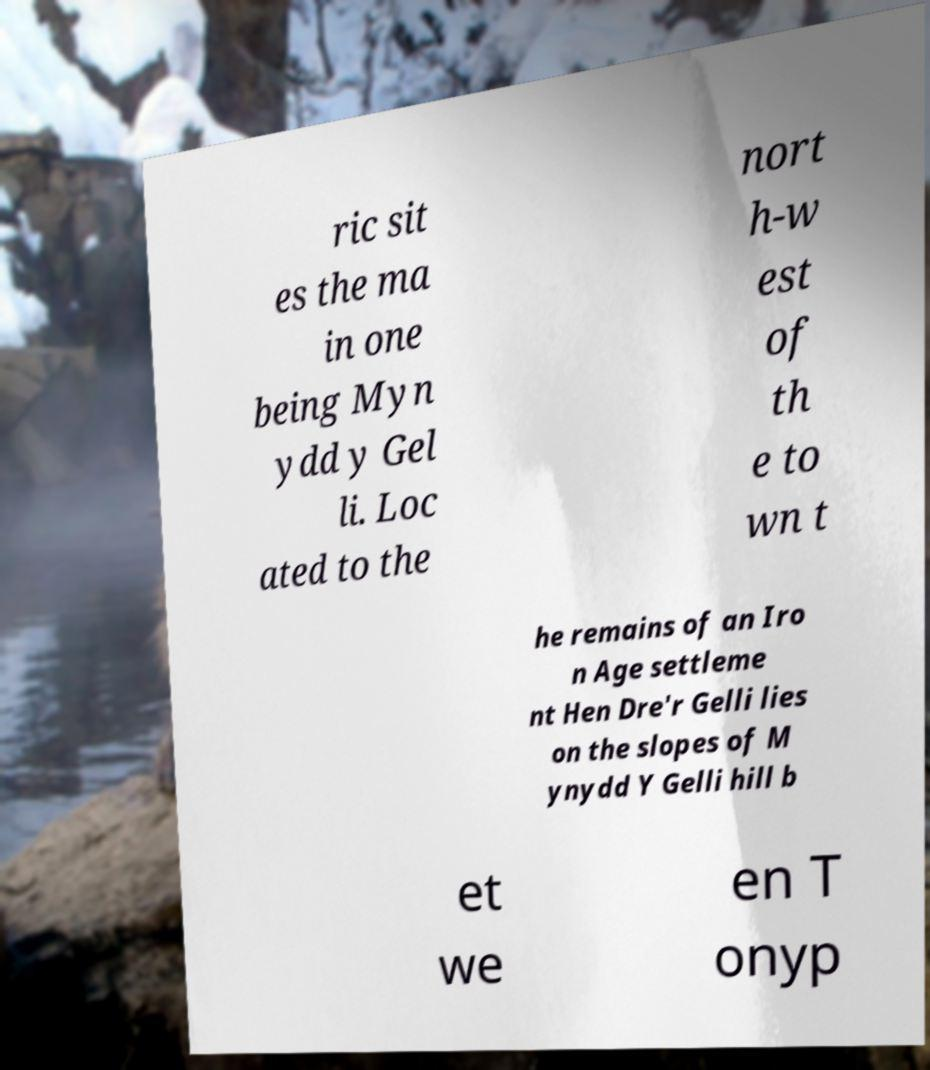Could you assist in decoding the text presented in this image and type it out clearly? ric sit es the ma in one being Myn ydd y Gel li. Loc ated to the nort h-w est of th e to wn t he remains of an Iro n Age settleme nt Hen Dre'r Gelli lies on the slopes of M ynydd Y Gelli hill b et we en T onyp 